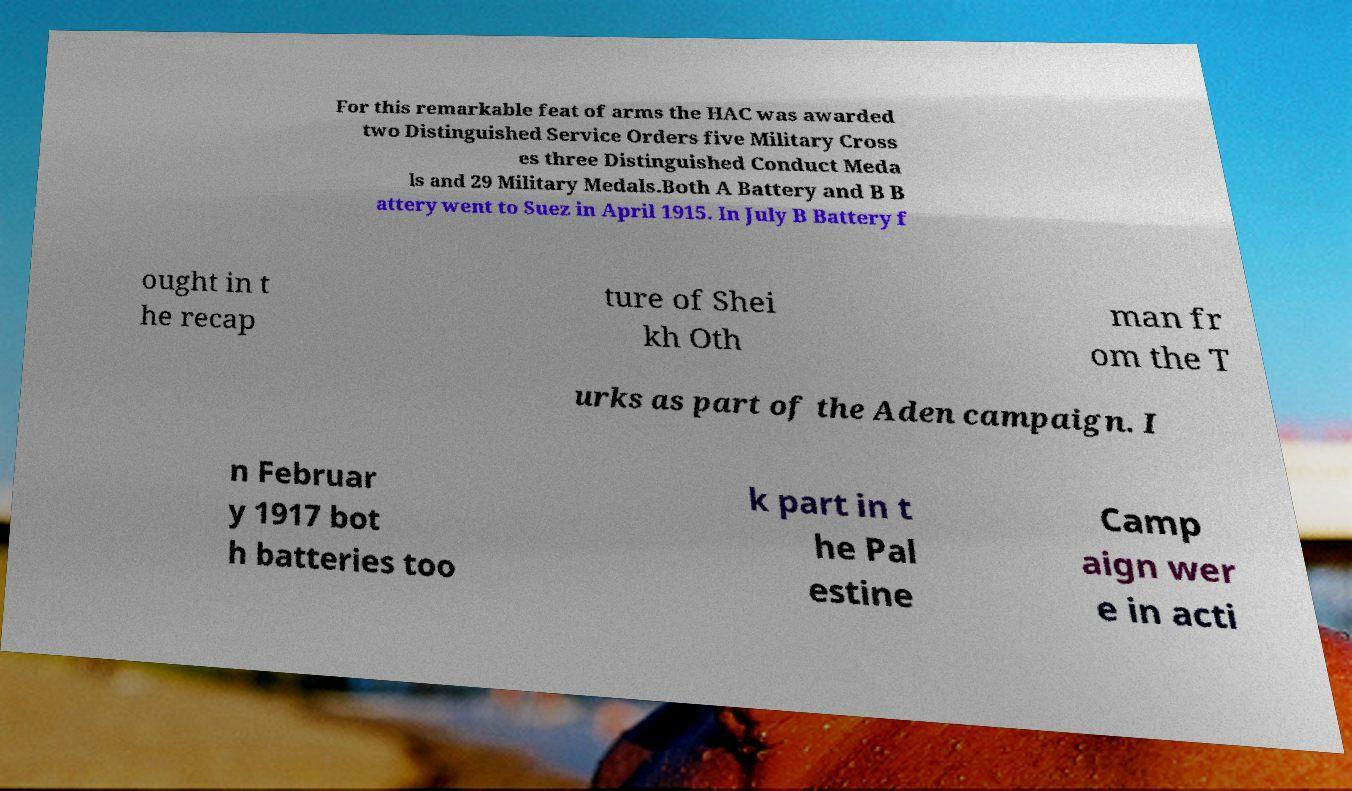I need the written content from this picture converted into text. Can you do that? For this remarkable feat of arms the HAC was awarded two Distinguished Service Orders five Military Cross es three Distinguished Conduct Meda ls and 29 Military Medals.Both A Battery and B B attery went to Suez in April 1915. In July B Battery f ought in t he recap ture of Shei kh Oth man fr om the T urks as part of the Aden campaign. I n Februar y 1917 bot h batteries too k part in t he Pal estine Camp aign wer e in acti 